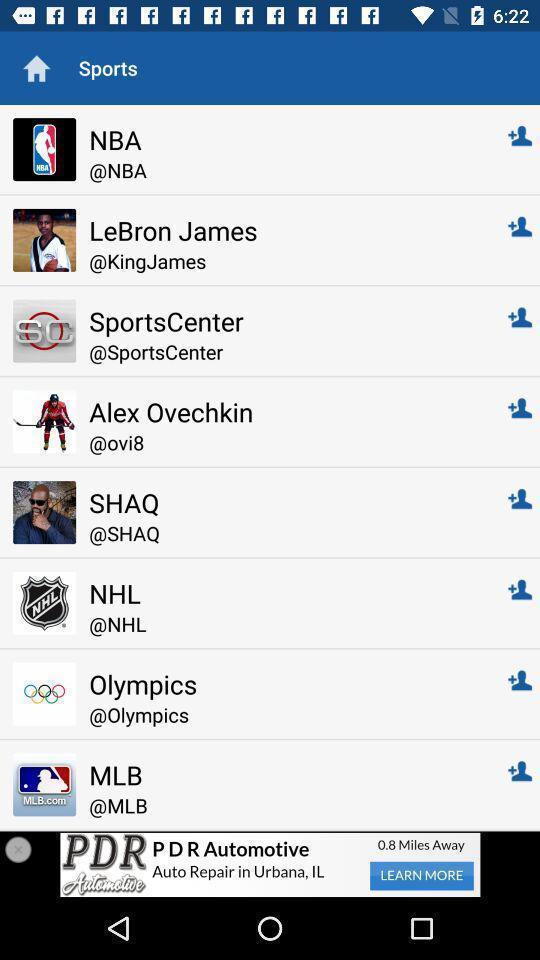Explain what's happening in this screen capture. Page showing different people and pages in a social app. 